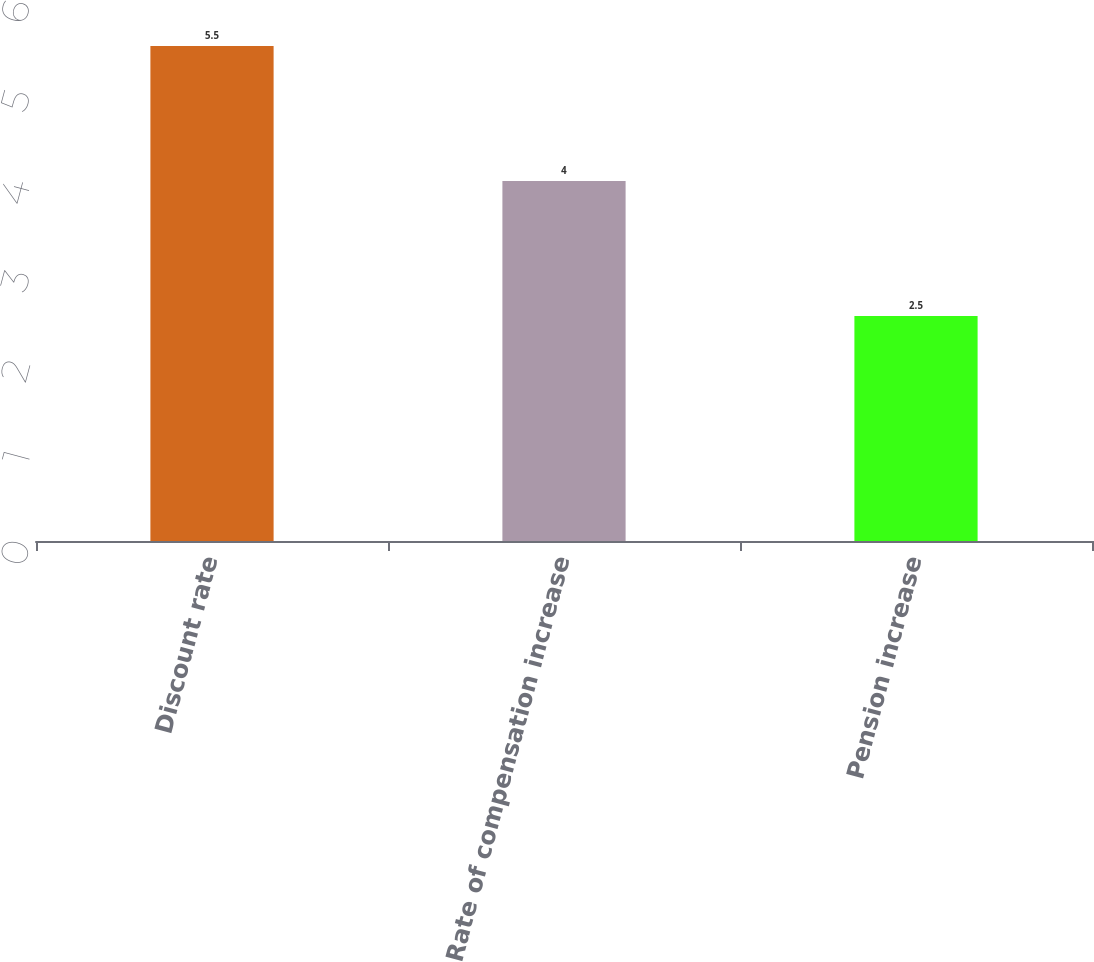Convert chart to OTSL. <chart><loc_0><loc_0><loc_500><loc_500><bar_chart><fcel>Discount rate<fcel>Rate of compensation increase<fcel>Pension increase<nl><fcel>5.5<fcel>4<fcel>2.5<nl></chart> 